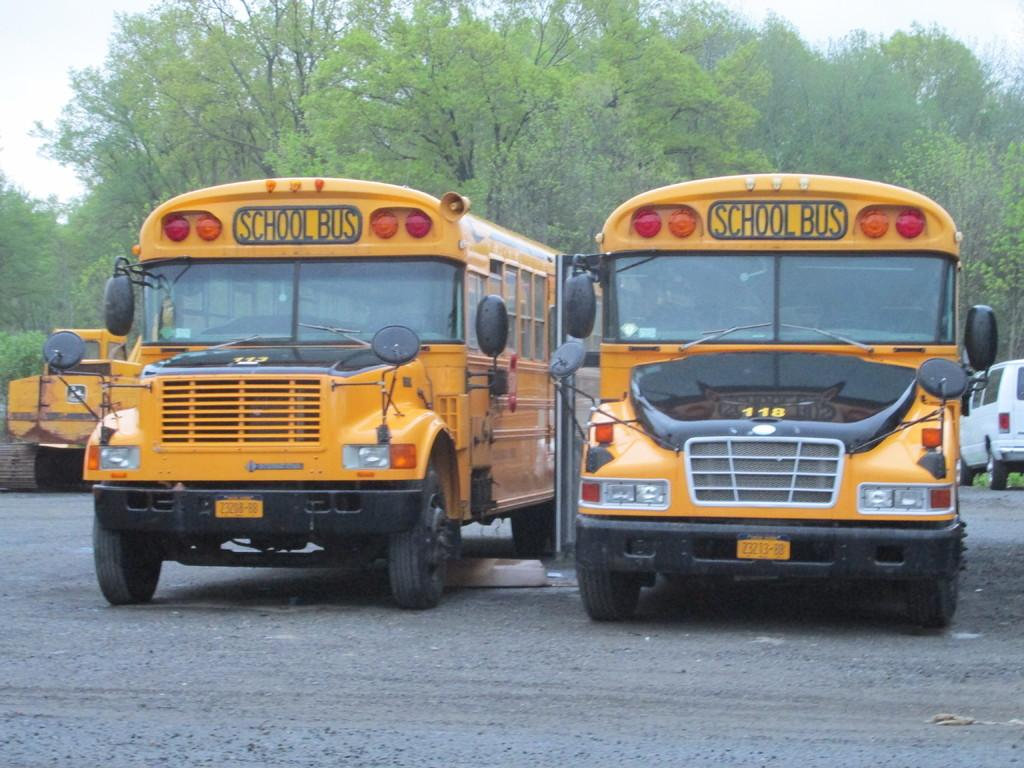What type of vehicles can be seen on the road in the image? There are buses on a road in the image. What can be seen in the background of the image? There are trees in the background of the image. What advertisement can be seen on the side of the buses in the image? There is no advertisement visible on the buses in the image. Can you tell me how many mothers are present in the image? There is no mother present in the image; it features buses on a road and trees in the background. 